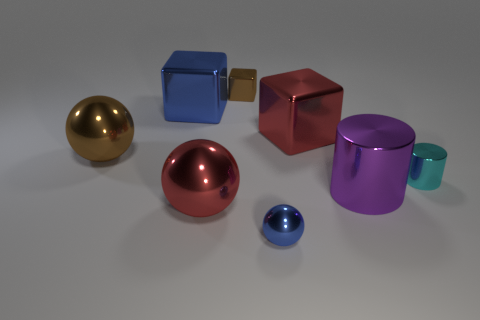Are there any other things that have the same size as the red shiny cube?
Provide a succinct answer. Yes. There is a sphere that is behind the purple metallic cylinder; is it the same size as the tiny metal sphere?
Keep it short and to the point. No. What material is the large red thing behind the purple shiny cylinder?
Offer a very short reply. Metal. Is there anything else that is the same shape as the cyan shiny thing?
Provide a short and direct response. Yes. What number of metal things are either small cubes or big red cubes?
Ensure brevity in your answer.  2. Is the number of blue shiny cubes left of the brown metal sphere less than the number of purple things?
Your answer should be compact. Yes. What shape is the big red thing to the left of the small metal thing behind the large shiny ball that is on the left side of the big red ball?
Ensure brevity in your answer.  Sphere. Do the tiny metallic cylinder and the small cube have the same color?
Give a very brief answer. No. Is the number of small cyan cylinders greater than the number of purple matte blocks?
Offer a very short reply. Yes. How many other objects are there of the same material as the large purple thing?
Offer a terse response. 7. 